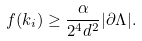<formula> <loc_0><loc_0><loc_500><loc_500>f ( k _ { i } ) \geq \frac { \alpha } { 2 ^ { 4 } d ^ { 2 } } | \partial \Lambda | .</formula> 